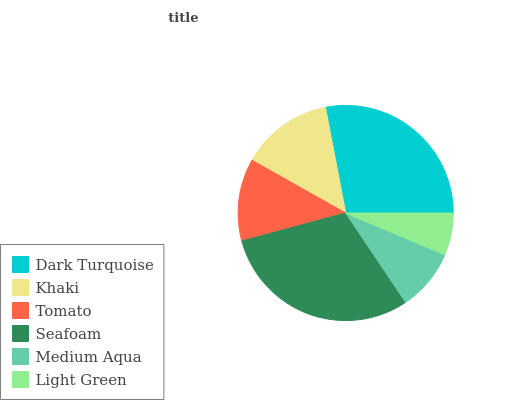Is Light Green the minimum?
Answer yes or no. Yes. Is Seafoam the maximum?
Answer yes or no. Yes. Is Khaki the minimum?
Answer yes or no. No. Is Khaki the maximum?
Answer yes or no. No. Is Dark Turquoise greater than Khaki?
Answer yes or no. Yes. Is Khaki less than Dark Turquoise?
Answer yes or no. Yes. Is Khaki greater than Dark Turquoise?
Answer yes or no. No. Is Dark Turquoise less than Khaki?
Answer yes or no. No. Is Khaki the high median?
Answer yes or no. Yes. Is Tomato the low median?
Answer yes or no. Yes. Is Seafoam the high median?
Answer yes or no. No. Is Khaki the low median?
Answer yes or no. No. 